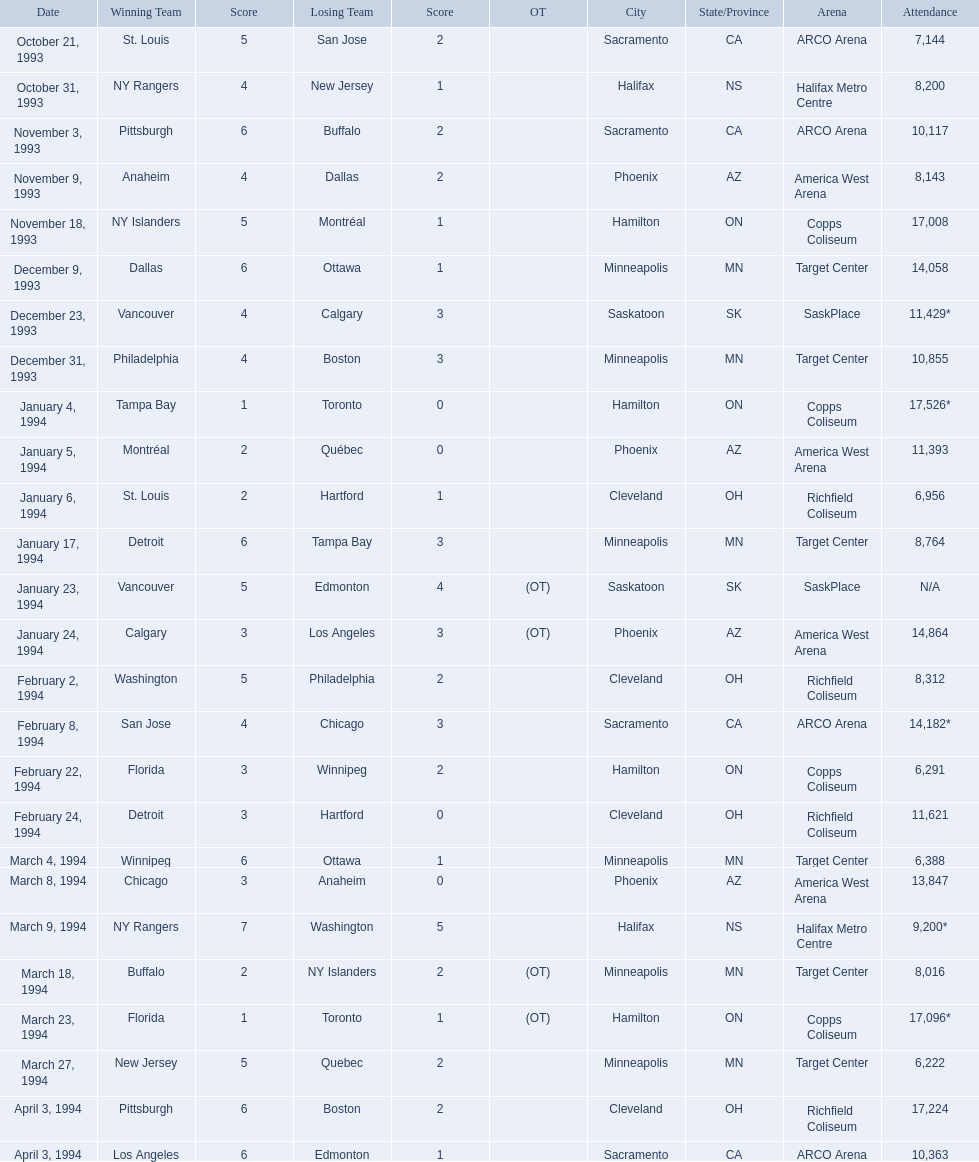When did the matches take place? October 21, 1993, October 31, 1993, November 3, 1993, November 9, 1993, November 18, 1993, December 9, 1993, December 23, 1993, December 31, 1993, January 4, 1994, January 5, 1994, January 6, 1994, January 17, 1994, January 23, 1994, January 24, 1994, February 2, 1994, February 8, 1994, February 22, 1994, February 24, 1994, March 4, 1994, March 8, 1994, March 9, 1994, March 18, 1994, March 23, 1994, March 27, 1994, April 3, 1994, April 3, 1994. What was the spectator count for those matches? 7,144, 8,200, 10,117, 8,143, 17,008, 14,058, 11,429*, 10,855, 17,526*, 11,393, 6,956, 8,764, N/A, 14,864, 8,312, 14,182*, 6,291, 11,621, 6,388, 13,847, 9,200*, 8,016, 17,096*, 6,222, 17,224, 10,363. On which date was the crowd the largest? January 4, 1994. 